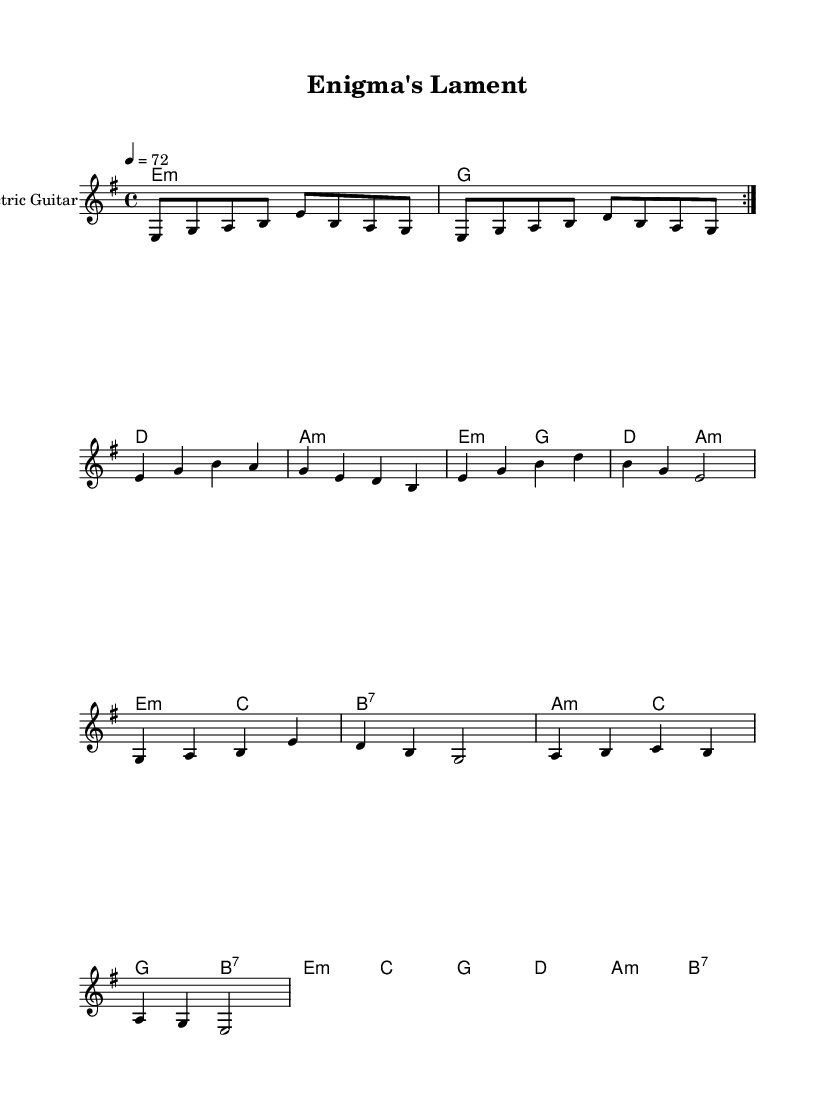What is the key signature of this music? The key signature is E minor, which has one sharp (F#). This can be identified by looking at the key signature at the beginning of the staff, which indicates the notes that will be sharp throughout the piece.
Answer: E minor What is the time signature of this music? The time signature is 4/4, shown at the beginning of the score. This means there are four beats in each measure and a quarter note gets one beat.
Answer: 4/4 What is the tempo marking for this piece? The tempo marking is 72 beats per minute, indicated by the "4 = 72" notation at the beginning. This means the quarter note is played at 72 beats per minute.
Answer: 72 How many measures are in the first section? There are four measures in the first section, which can be determined by counting the bars in the "guitarRiff" section before the first break. Each set of notes is separated by a bar line.
Answer: 4 Which chords are used in the harmonies section? The chords in the harmonies section include E minor, G major, D major, and A minor, as indicated by the chord symbols above the staff.
Answer: E minor, G major, D major, A minor What kind of musical mood does this piece convey? The piece conveys a dark and mysterious mood, which is characteristic of electric blues. This can be deduced from the minor key and the haunting melody lines.
Answer: Dark and mysterious How does the melody in the verse differ from the chorus? The melody in the verse is more subdued with an emphasis on lower notes, while the chorus features higher notes and a more dynamic rhythm, highlighting the contrast between sections.
Answer: More subdued in verse, dynamic in chorus 